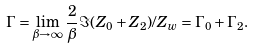Convert formula to latex. <formula><loc_0><loc_0><loc_500><loc_500>\Gamma = \lim _ { \beta \to \infty } \frac { 2 } { \beta } \Im ( Z _ { 0 } + Z _ { 2 } ) / Z _ { w } = \Gamma _ { 0 } + \Gamma _ { 2 } .</formula> 